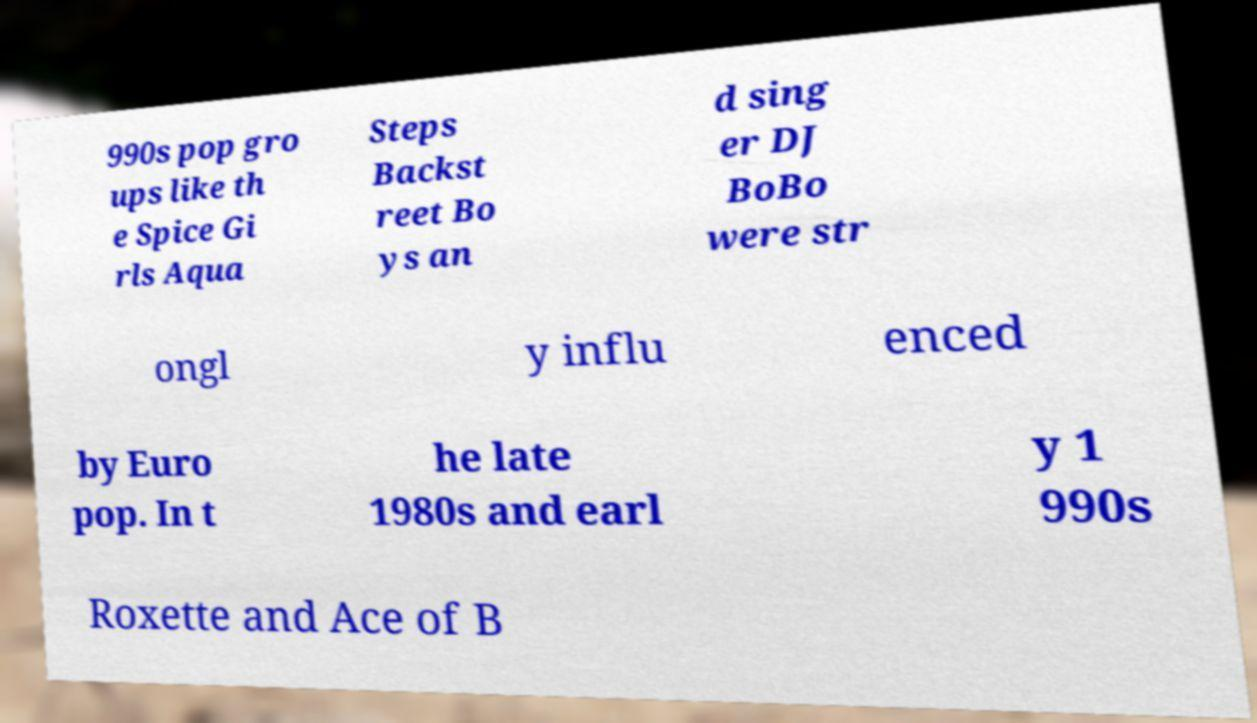Please identify and transcribe the text found in this image. 990s pop gro ups like th e Spice Gi rls Aqua Steps Backst reet Bo ys an d sing er DJ BoBo were str ongl y influ enced by Euro pop. In t he late 1980s and earl y 1 990s Roxette and Ace of B 